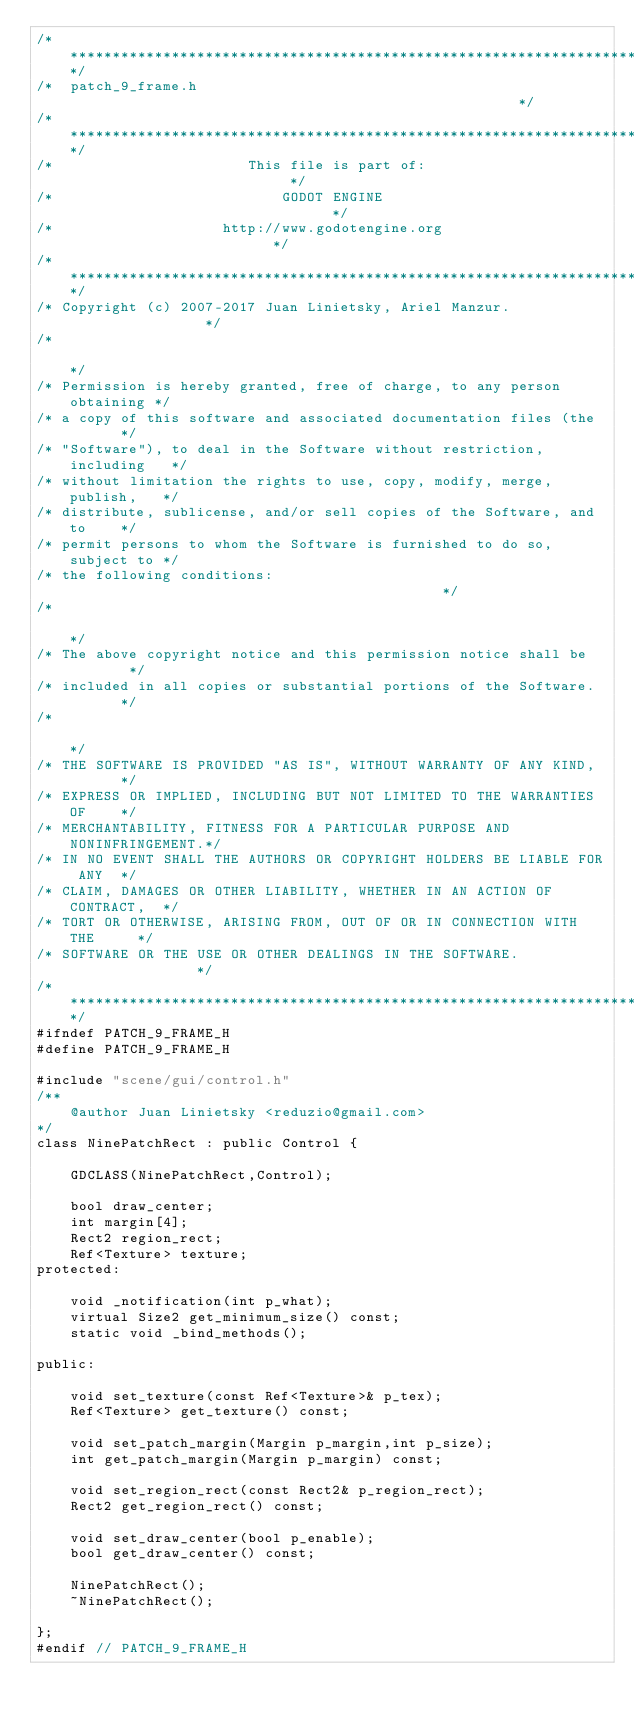<code> <loc_0><loc_0><loc_500><loc_500><_C_>/*************************************************************************/
/*  patch_9_frame.h                                                      */
/*************************************************************************/
/*                       This file is part of:                           */
/*                           GODOT ENGINE                                */
/*                    http://www.godotengine.org                         */
/*************************************************************************/
/* Copyright (c) 2007-2017 Juan Linietsky, Ariel Manzur.                 */
/*                                                                       */
/* Permission is hereby granted, free of charge, to any person obtaining */
/* a copy of this software and associated documentation files (the       */
/* "Software"), to deal in the Software without restriction, including   */
/* without limitation the rights to use, copy, modify, merge, publish,   */
/* distribute, sublicense, and/or sell copies of the Software, and to    */
/* permit persons to whom the Software is furnished to do so, subject to */
/* the following conditions:                                             */
/*                                                                       */
/* The above copyright notice and this permission notice shall be        */
/* included in all copies or substantial portions of the Software.       */
/*                                                                       */
/* THE SOFTWARE IS PROVIDED "AS IS", WITHOUT WARRANTY OF ANY KIND,       */
/* EXPRESS OR IMPLIED, INCLUDING BUT NOT LIMITED TO THE WARRANTIES OF    */
/* MERCHANTABILITY, FITNESS FOR A PARTICULAR PURPOSE AND NONINFRINGEMENT.*/
/* IN NO EVENT SHALL THE AUTHORS OR COPYRIGHT HOLDERS BE LIABLE FOR ANY  */
/* CLAIM, DAMAGES OR OTHER LIABILITY, WHETHER IN AN ACTION OF CONTRACT,  */
/* TORT OR OTHERWISE, ARISING FROM, OUT OF OR IN CONNECTION WITH THE     */
/* SOFTWARE OR THE USE OR OTHER DEALINGS IN THE SOFTWARE.                */
/*************************************************************************/
#ifndef PATCH_9_FRAME_H
#define PATCH_9_FRAME_H

#include "scene/gui/control.h"
/**
	@author Juan Linietsky <reduzio@gmail.com>
*/
class NinePatchRect : public Control {

	GDCLASS(NinePatchRect,Control);

	bool draw_center;
	int margin[4];
	Rect2 region_rect;
	Ref<Texture> texture;
protected:

	void _notification(int p_what);
	virtual Size2 get_minimum_size() const;
	static void _bind_methods();

public:

	void set_texture(const Ref<Texture>& p_tex);
	Ref<Texture> get_texture() const;

	void set_patch_margin(Margin p_margin,int p_size);
	int get_patch_margin(Margin p_margin) const;

	void set_region_rect(const Rect2& p_region_rect);
	Rect2 get_region_rect() const;

	void set_draw_center(bool p_enable);
	bool get_draw_center() const;

	NinePatchRect();
	~NinePatchRect();

};
#endif // PATCH_9_FRAME_H
</code> 